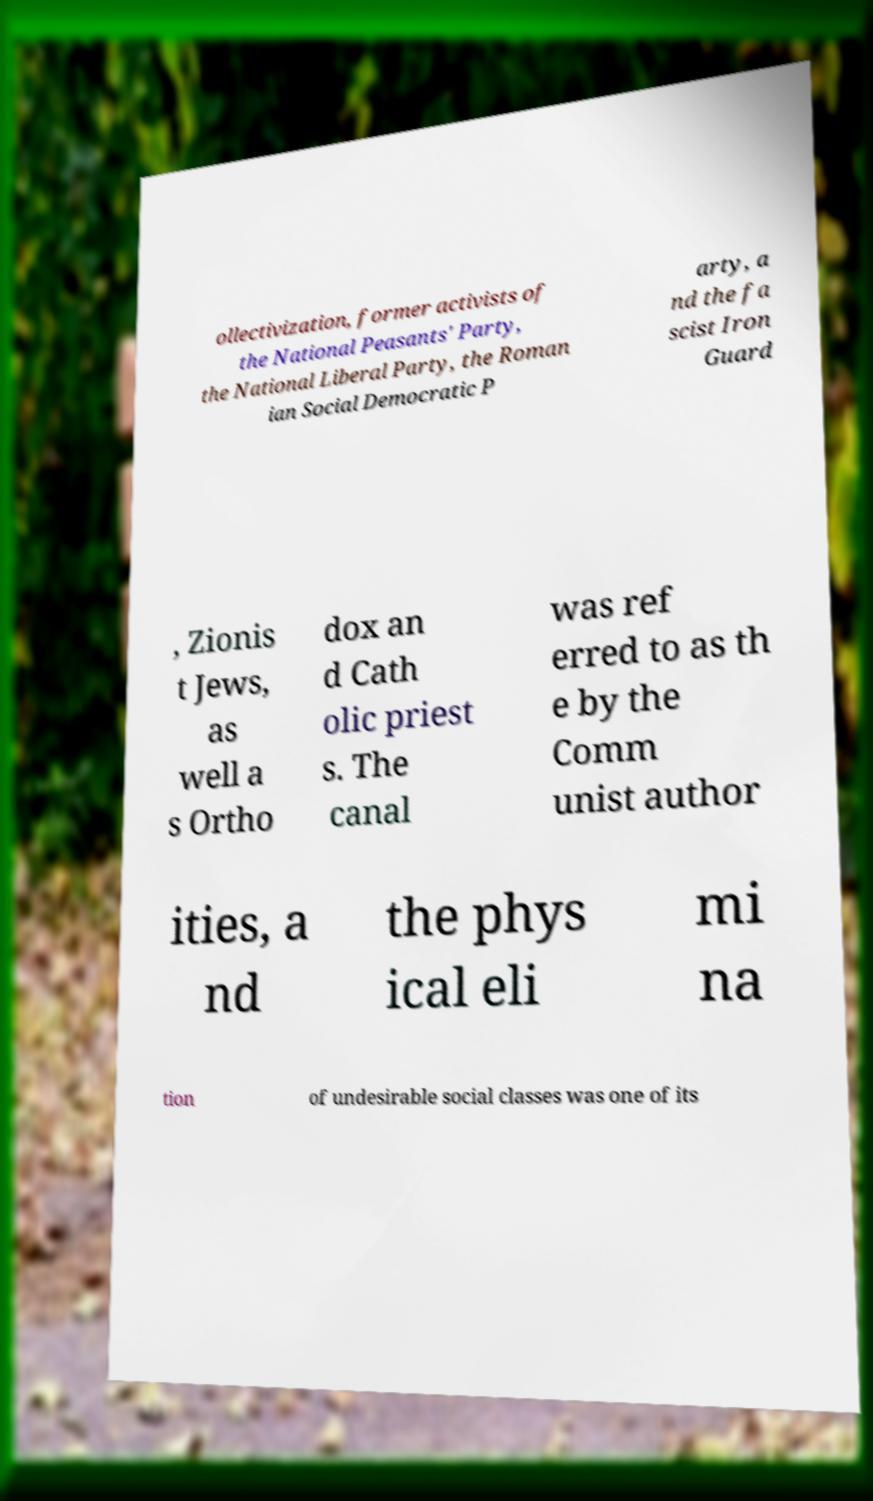Can you read and provide the text displayed in the image?This photo seems to have some interesting text. Can you extract and type it out for me? ollectivization, former activists of the National Peasants' Party, the National Liberal Party, the Roman ian Social Democratic P arty, a nd the fa scist Iron Guard , Zionis t Jews, as well a s Ortho dox an d Cath olic priest s. The canal was ref erred to as th e by the Comm unist author ities, a nd the phys ical eli mi na tion of undesirable social classes was one of its 